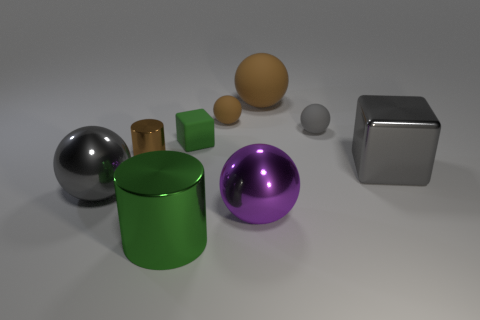Add 1 tiny gray things. How many objects exist? 10 Subtract all brown spheres. How many spheres are left? 3 Subtract 1 cylinders. How many cylinders are left? 1 Subtract all brown spheres. How many spheres are left? 3 Subtract all cyan cubes. Subtract all purple spheres. How many cubes are left? 2 Subtract all yellow blocks. How many cyan balls are left? 0 Subtract all small green rubber balls. Subtract all big balls. How many objects are left? 6 Add 8 big brown matte spheres. How many big brown matte spheres are left? 9 Add 3 cubes. How many cubes exist? 5 Subtract 0 yellow spheres. How many objects are left? 9 